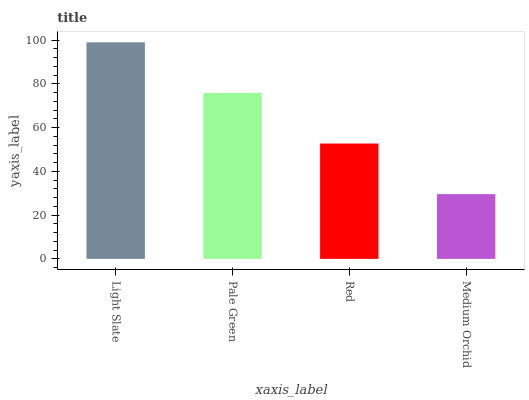Is Medium Orchid the minimum?
Answer yes or no. Yes. Is Light Slate the maximum?
Answer yes or no. Yes. Is Pale Green the minimum?
Answer yes or no. No. Is Pale Green the maximum?
Answer yes or no. No. Is Light Slate greater than Pale Green?
Answer yes or no. Yes. Is Pale Green less than Light Slate?
Answer yes or no. Yes. Is Pale Green greater than Light Slate?
Answer yes or no. No. Is Light Slate less than Pale Green?
Answer yes or no. No. Is Pale Green the high median?
Answer yes or no. Yes. Is Red the low median?
Answer yes or no. Yes. Is Red the high median?
Answer yes or no. No. Is Light Slate the low median?
Answer yes or no. No. 